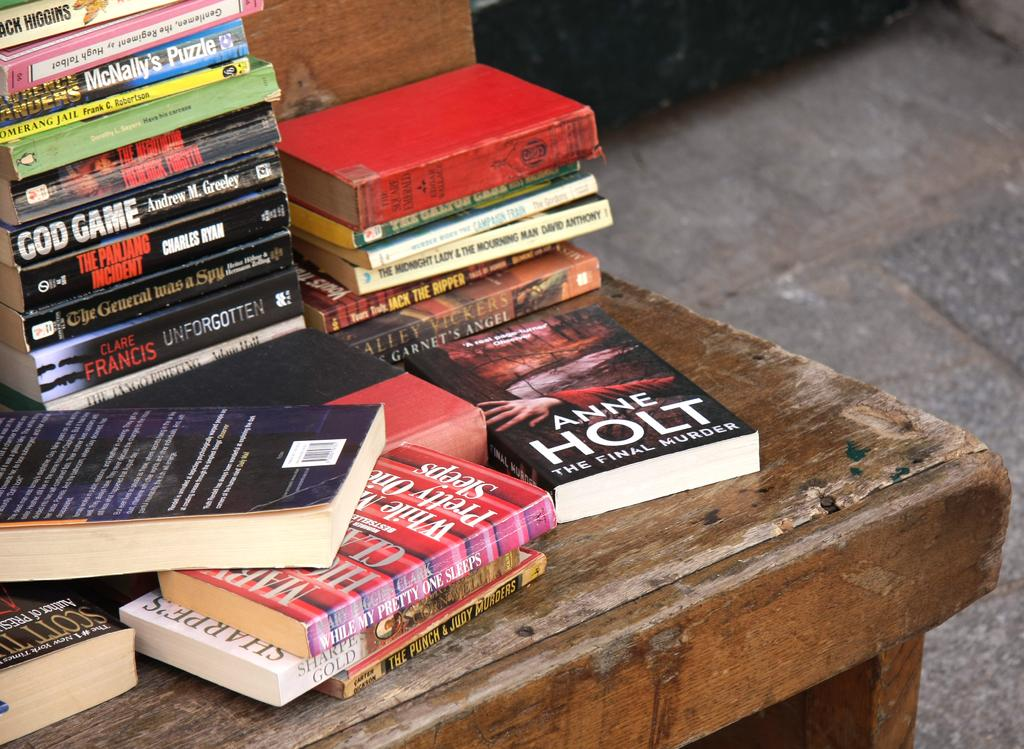<image>
Describe the image concisely. A book by Anne Holt is on a table with other books. 